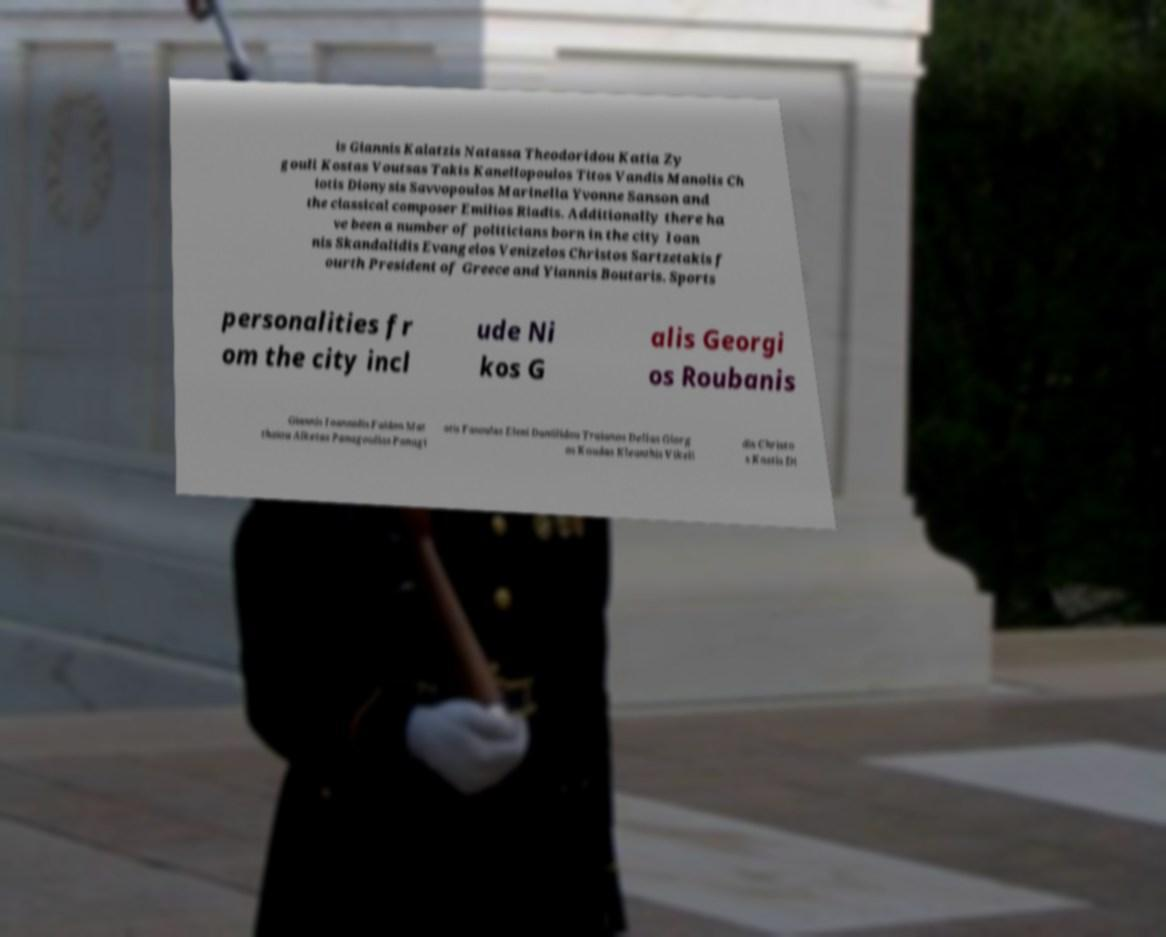Could you assist in decoding the text presented in this image and type it out clearly? is Giannis Kalatzis Natassa Theodoridou Katia Zy gouli Kostas Voutsas Takis Kanellopoulos Titos Vandis Manolis Ch iotis Dionysis Savvopoulos Marinella Yvonne Sanson and the classical composer Emilios Riadis. Additionally there ha ve been a number of politicians born in the city Ioan nis Skandalidis Evangelos Venizelos Christos Sartzetakis f ourth President of Greece and Yiannis Boutaris. Sports personalities fr om the city incl ude Ni kos G alis Georgi os Roubanis Giannis Ioannidis Faidon Mat thaiou Alketas Panagoulias Panagi otis Fasoulas Eleni Daniilidou Traianos Dellas Giorg os Koudas Kleanthis Vikeli dis Christo s Kostis Di 